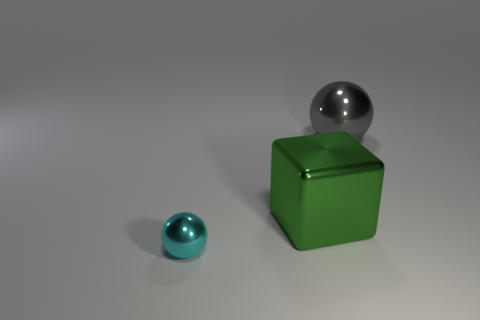If the small cyan object were to be placed on top of the big green cube, how would the composition of the image change? Placing the small cyan object atop the green cube would create a new focal point in the image, drawing the viewer's attention upward and altering the balance of elements, ultimately leading to a more vertical composition. 